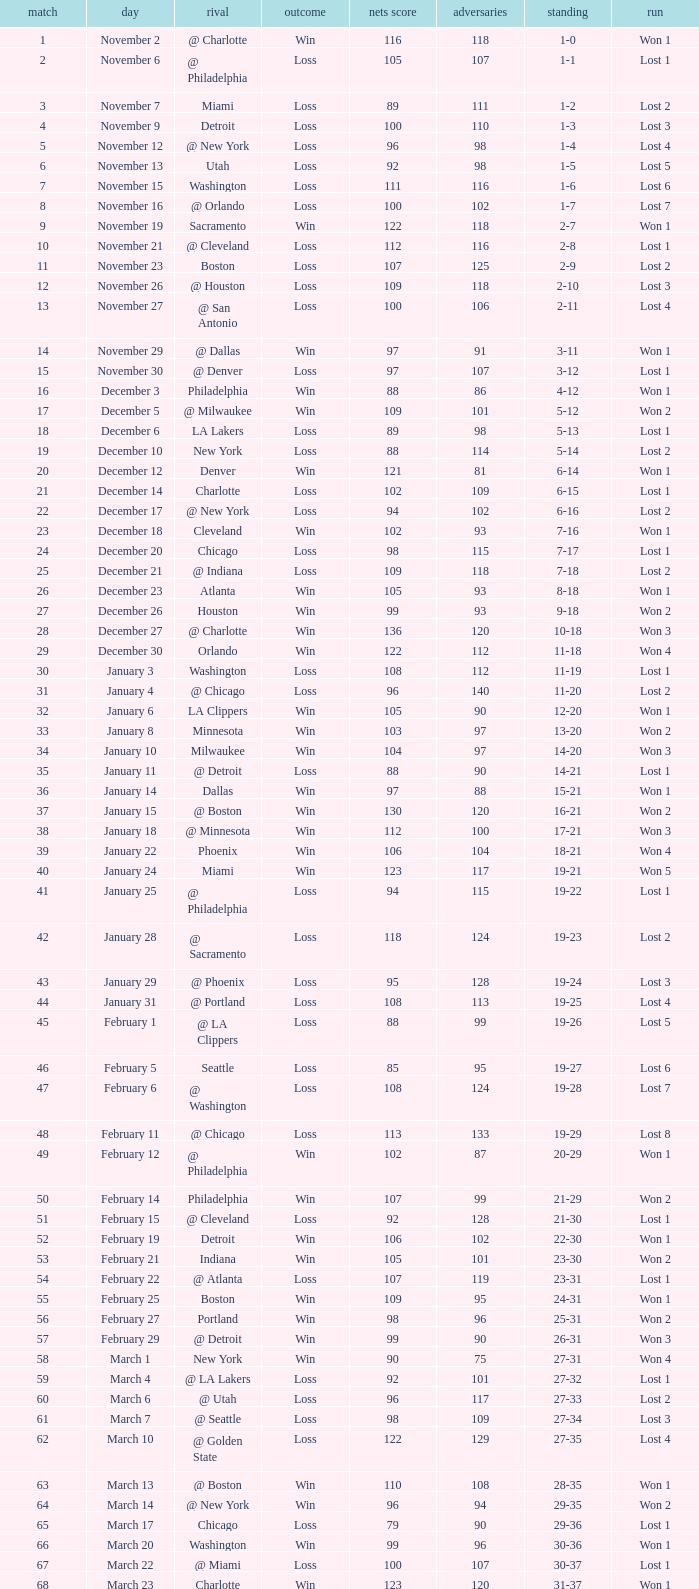Write the full table. {'header': ['match', 'day', 'rival', 'outcome', 'nets score', 'adversaries', 'standing', 'run'], 'rows': [['1', 'November 2', '@ Charlotte', 'Win', '116', '118', '1-0', 'Won 1'], ['2', 'November 6', '@ Philadelphia', 'Loss', '105', '107', '1-1', 'Lost 1'], ['3', 'November 7', 'Miami', 'Loss', '89', '111', '1-2', 'Lost 2'], ['4', 'November 9', 'Detroit', 'Loss', '100', '110', '1-3', 'Lost 3'], ['5', 'November 12', '@ New York', 'Loss', '96', '98', '1-4', 'Lost 4'], ['6', 'November 13', 'Utah', 'Loss', '92', '98', '1-5', 'Lost 5'], ['7', 'November 15', 'Washington', 'Loss', '111', '116', '1-6', 'Lost 6'], ['8', 'November 16', '@ Orlando', 'Loss', '100', '102', '1-7', 'Lost 7'], ['9', 'November 19', 'Sacramento', 'Win', '122', '118', '2-7', 'Won 1'], ['10', 'November 21', '@ Cleveland', 'Loss', '112', '116', '2-8', 'Lost 1'], ['11', 'November 23', 'Boston', 'Loss', '107', '125', '2-9', 'Lost 2'], ['12', 'November 26', '@ Houston', 'Loss', '109', '118', '2-10', 'Lost 3'], ['13', 'November 27', '@ San Antonio', 'Loss', '100', '106', '2-11', 'Lost 4'], ['14', 'November 29', '@ Dallas', 'Win', '97', '91', '3-11', 'Won 1'], ['15', 'November 30', '@ Denver', 'Loss', '97', '107', '3-12', 'Lost 1'], ['16', 'December 3', 'Philadelphia', 'Win', '88', '86', '4-12', 'Won 1'], ['17', 'December 5', '@ Milwaukee', 'Win', '109', '101', '5-12', 'Won 2'], ['18', 'December 6', 'LA Lakers', 'Loss', '89', '98', '5-13', 'Lost 1'], ['19', 'December 10', 'New York', 'Loss', '88', '114', '5-14', 'Lost 2'], ['20', 'December 12', 'Denver', 'Win', '121', '81', '6-14', 'Won 1'], ['21', 'December 14', 'Charlotte', 'Loss', '102', '109', '6-15', 'Lost 1'], ['22', 'December 17', '@ New York', 'Loss', '94', '102', '6-16', 'Lost 2'], ['23', 'December 18', 'Cleveland', 'Win', '102', '93', '7-16', 'Won 1'], ['24', 'December 20', 'Chicago', 'Loss', '98', '115', '7-17', 'Lost 1'], ['25', 'December 21', '@ Indiana', 'Loss', '109', '118', '7-18', 'Lost 2'], ['26', 'December 23', 'Atlanta', 'Win', '105', '93', '8-18', 'Won 1'], ['27', 'December 26', 'Houston', 'Win', '99', '93', '9-18', 'Won 2'], ['28', 'December 27', '@ Charlotte', 'Win', '136', '120', '10-18', 'Won 3'], ['29', 'December 30', 'Orlando', 'Win', '122', '112', '11-18', 'Won 4'], ['30', 'January 3', 'Washington', 'Loss', '108', '112', '11-19', 'Lost 1'], ['31', 'January 4', '@ Chicago', 'Loss', '96', '140', '11-20', 'Lost 2'], ['32', 'January 6', 'LA Clippers', 'Win', '105', '90', '12-20', 'Won 1'], ['33', 'January 8', 'Minnesota', 'Win', '103', '97', '13-20', 'Won 2'], ['34', 'January 10', 'Milwaukee', 'Win', '104', '97', '14-20', 'Won 3'], ['35', 'January 11', '@ Detroit', 'Loss', '88', '90', '14-21', 'Lost 1'], ['36', 'January 14', 'Dallas', 'Win', '97', '88', '15-21', 'Won 1'], ['37', 'January 15', '@ Boston', 'Win', '130', '120', '16-21', 'Won 2'], ['38', 'January 18', '@ Minnesota', 'Win', '112', '100', '17-21', 'Won 3'], ['39', 'January 22', 'Phoenix', 'Win', '106', '104', '18-21', 'Won 4'], ['40', 'January 24', 'Miami', 'Win', '123', '117', '19-21', 'Won 5'], ['41', 'January 25', '@ Philadelphia', 'Loss', '94', '115', '19-22', 'Lost 1'], ['42', 'January 28', '@ Sacramento', 'Loss', '118', '124', '19-23', 'Lost 2'], ['43', 'January 29', '@ Phoenix', 'Loss', '95', '128', '19-24', 'Lost 3'], ['44', 'January 31', '@ Portland', 'Loss', '108', '113', '19-25', 'Lost 4'], ['45', 'February 1', '@ LA Clippers', 'Loss', '88', '99', '19-26', 'Lost 5'], ['46', 'February 5', 'Seattle', 'Loss', '85', '95', '19-27', 'Lost 6'], ['47', 'February 6', '@ Washington', 'Loss', '108', '124', '19-28', 'Lost 7'], ['48', 'February 11', '@ Chicago', 'Loss', '113', '133', '19-29', 'Lost 8'], ['49', 'February 12', '@ Philadelphia', 'Win', '102', '87', '20-29', 'Won 1'], ['50', 'February 14', 'Philadelphia', 'Win', '107', '99', '21-29', 'Won 2'], ['51', 'February 15', '@ Cleveland', 'Loss', '92', '128', '21-30', 'Lost 1'], ['52', 'February 19', 'Detroit', 'Win', '106', '102', '22-30', 'Won 1'], ['53', 'February 21', 'Indiana', 'Win', '105', '101', '23-30', 'Won 2'], ['54', 'February 22', '@ Atlanta', 'Loss', '107', '119', '23-31', 'Lost 1'], ['55', 'February 25', 'Boston', 'Win', '109', '95', '24-31', 'Won 1'], ['56', 'February 27', 'Portland', 'Win', '98', '96', '25-31', 'Won 2'], ['57', 'February 29', '@ Detroit', 'Win', '99', '90', '26-31', 'Won 3'], ['58', 'March 1', 'New York', 'Win', '90', '75', '27-31', 'Won 4'], ['59', 'March 4', '@ LA Lakers', 'Loss', '92', '101', '27-32', 'Lost 1'], ['60', 'March 6', '@ Utah', 'Loss', '96', '117', '27-33', 'Lost 2'], ['61', 'March 7', '@ Seattle', 'Loss', '98', '109', '27-34', 'Lost 3'], ['62', 'March 10', '@ Golden State', 'Loss', '122', '129', '27-35', 'Lost 4'], ['63', 'March 13', '@ Boston', 'Win', '110', '108', '28-35', 'Won 1'], ['64', 'March 14', '@ New York', 'Win', '96', '94', '29-35', 'Won 2'], ['65', 'March 17', 'Chicago', 'Loss', '79', '90', '29-36', 'Lost 1'], ['66', 'March 20', 'Washington', 'Win', '99', '96', '30-36', 'Won 1'], ['67', 'March 22', '@ Miami', 'Loss', '100', '107', '30-37', 'Lost 1'], ['68', 'March 23', 'Charlotte', 'Win', '123', '120', '31-37', 'Won 1'], ['69', 'March 25', 'Boston', 'Loss', '110', '118', '31-38', 'Lost 1'], ['70', 'March 28', 'Golden State', 'Loss', '148', '153', '31-39', 'Lost 2'], ['71', 'March 30', 'San Antonio', 'Win', '117', '109', '32-39', 'Won 1'], ['72', 'April 1', '@ Milwaukee', 'Win', '121', '117', '33-39', 'Won 2'], ['73', 'April 3', 'Milwaukee', 'Win', '122', '103', '34-39', 'Won 3'], ['74', 'April 5', '@ Indiana', 'Win', '128', '120', '35-39', 'Won 4'], ['75', 'April 7', 'Atlanta', 'Loss', '97', '104', '35-40', 'Lost 1'], ['76', 'April 8', '@ Washington', 'Win', '109', '103', '36-40', 'Won 1'], ['77', 'April 10', 'Cleveland', 'Win', '110', '86', '37-40', 'Won 2'], ['78', 'April 11', '@ Atlanta', 'Loss', '98', '118', '37-41', 'Lost 1'], ['79', 'April 13', '@ Orlando', 'Win', '110', '104', '38-41', 'Won 1'], ['80', 'April 14', '@ Miami', 'Win', '105', '100', '39-41', 'Won 2'], ['81', 'April 16', 'Indiana', 'Loss', '113', '119', '39-42', 'Lost 1'], ['82', 'April 18', 'Orlando', 'Win', '127', '111', '40-42', 'Won 1'], ['1', 'April 23', '@ Cleveland', 'Loss', '113', '120', '0-1', 'Lost 1'], ['2', 'April 25', '@ Cleveland', 'Loss', '96', '118', '0-2', 'Lost 2'], ['3', 'April 28', 'Cleveland', 'Win', '109', '104', '1-2', 'Won 1'], ['4', 'April 30', 'Cleveland', 'Loss', '89', '98', '1-3', 'Lost 1']]} How many opponents were there in a game higher than 20 on January 28? 124.0. 